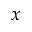<formula> <loc_0><loc_0><loc_500><loc_500>x</formula> 